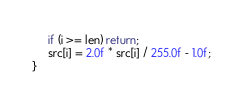Convert code to text. <code><loc_0><loc_0><loc_500><loc_500><_Cuda_>     if (i >= len) return;
     src[i] = 2.0f * src[i] / 255.0f - 1.0f;
}
</code> 